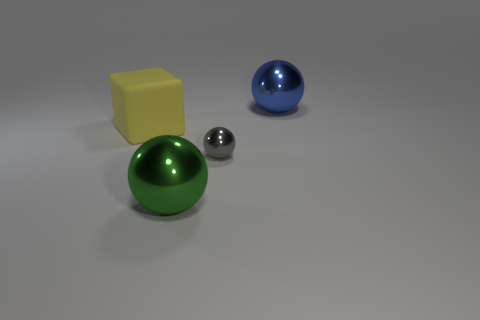Subtract 1 balls. How many balls are left? 2 Add 2 large green balls. How many objects exist? 6 Subtract all spheres. How many objects are left? 1 Add 1 small green metal blocks. How many small green metal blocks exist? 1 Subtract 0 green blocks. How many objects are left? 4 Subtract all gray things. Subtract all large purple matte balls. How many objects are left? 3 Add 1 big blue things. How many big blue things are left? 2 